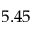Convert formula to latex. <formula><loc_0><loc_0><loc_500><loc_500>5 . 4 5</formula> 